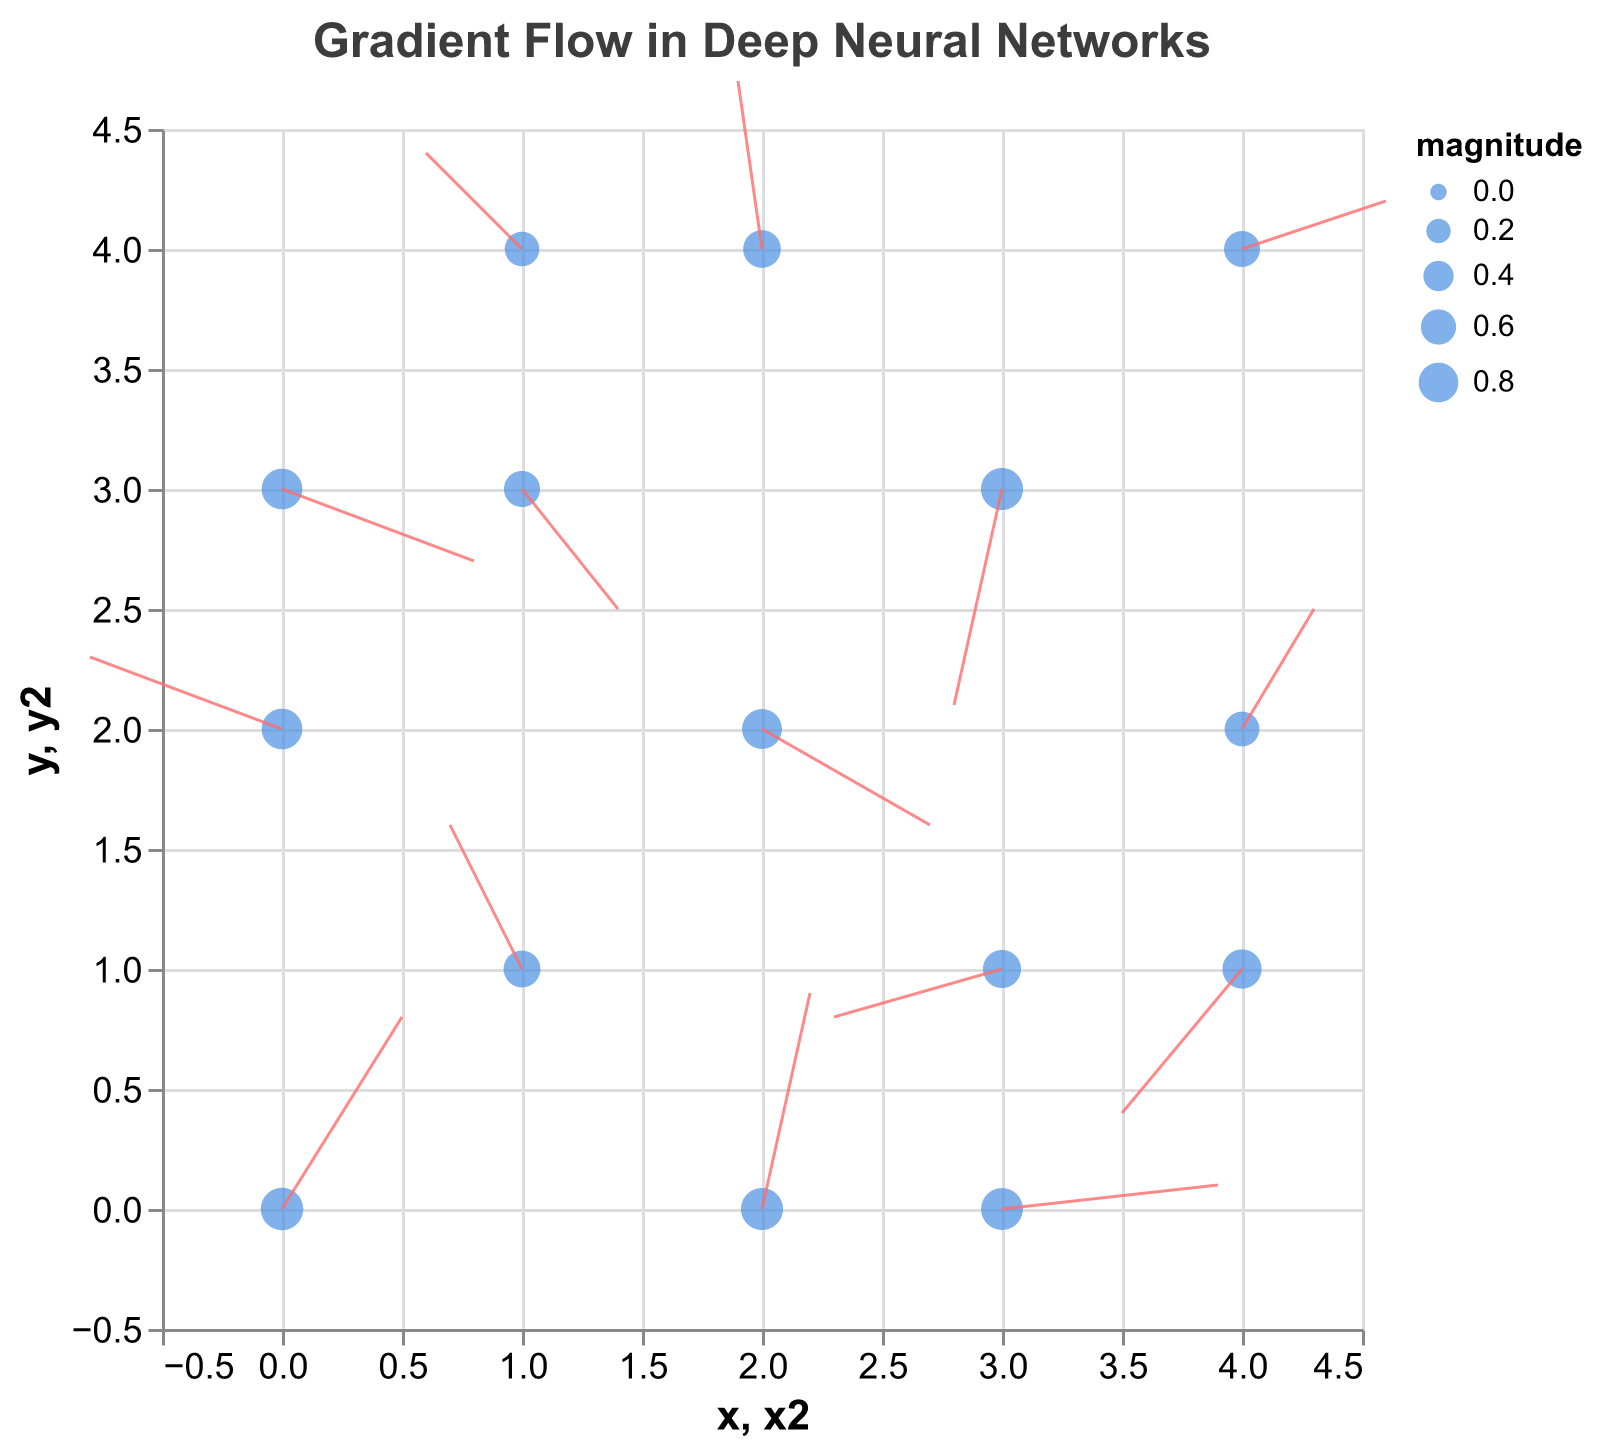What is the title of the figure? The title is displayed at the top of the figure and reads "Gradient Flow in Deep Neural Networks".
Answer: Gradient Flow in Deep Neural Networks How many data points are plotted in the figure? The figure shows 15 pairs of (x, y) coordinates with corresponding arrows and magnitudes, each representing a data point.
Answer: 15 What is the direction of the gradient flow at coordinates (3, 3)? From the data, the point at (3, 3) has (u, v) values of (-0.2, -0.9). This means the gradient flow direction is towards (-0.2, -0.9) from (3, 3).
Answer: Towards (-0.2, -0.9) Which data point has the largest magnitude? The magnitudes are given for each point; the largest magnitude is 0.94 which corresponds to the point at (0, 0).
Answer: (0, 0) At which points does the gradient flow predominantly in the positive x and y directions? To find points where the gradient flow (u, v) is positive in both x and y directions, we look for points with positive u and v values in the data. These points are (0, 0) and (2, 0).
Answer: (0, 0) and (2, 0) Is there any point where the gradient flow is predominantly negative in both the x and y directions? The gradient flow (u, v) must be negative for both components. From the data, the point at (3, 3) has negative values for both u and v (-0.2, -0.9).
Answer: (3, 3) What is the total magnitude of the gradient flow vectors at coordinates (0, 2) and (1, 1)? The magnitudes at (0, 2) and (1, 1) are 0.85 and 0.67, respectively. Summing these up: 0.85 + 0.67 = 1.52.
Answer: 1.52 Which data point has the smallest magnitude? By examining the provided data, the smallest magnitude is 0.57 which corresponds to the point at (1, 4).
Answer: (1, 4) What is the average magnitude of the gradient flow vectors? Summing all magnitudes and then dividing by the number of points: (0.94 + 0.67 + 0.81 + 0.92 + 0.63 + 0.85 + 0.64 + 0.71 + 0.91 + 0.78 + 0.92 + 0.73 + 0.58 + 0.85 + 0.57) / 15 = 11.51 / 15 = 0.767.
Answer: 0.767 